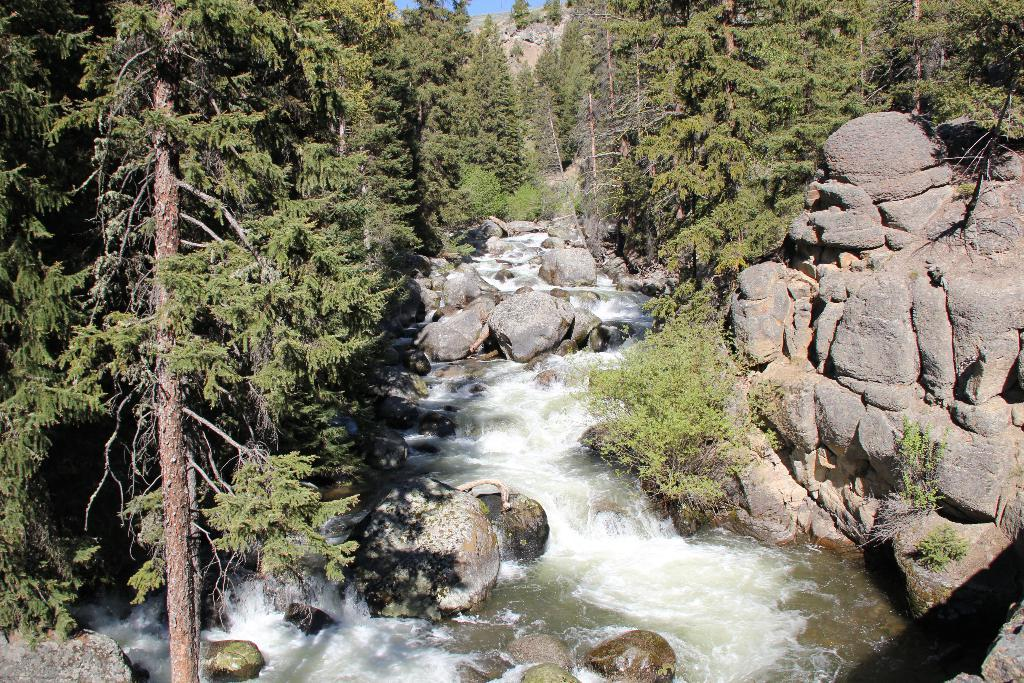What is one of the main elements in the image? There is water in the image. What other natural features can be seen in the image? There are rocks, plants, and trees in the image. What is the color of the sky in the image? The sky is blue in the image. How many geese are flying over the trees in the image? There are no geese present in the image. Can you see a plane flying in the blue sky in the image? There is no plane visible in the image. 